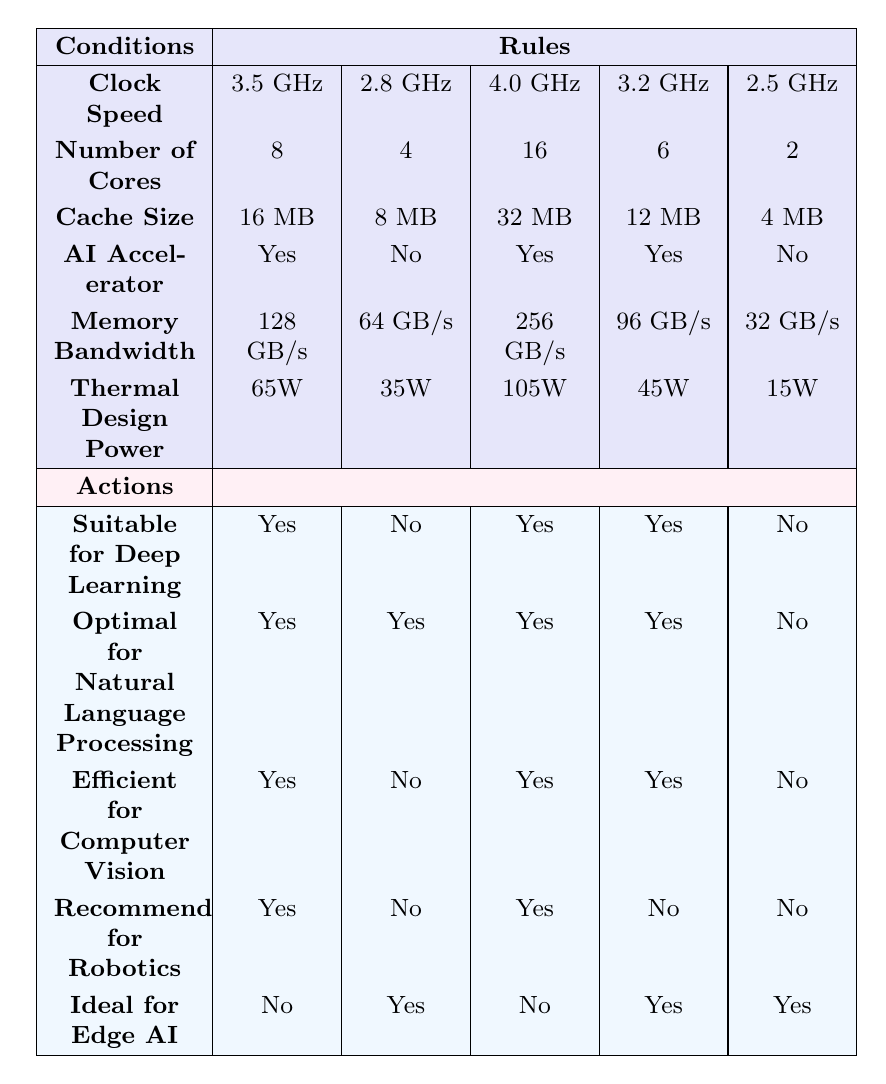What is the clock speed of the microprocessor suitable for deep learning? There are three entries in the table that indicate suitability for deep learning: 3.5 GHz, 4.0 GHz, and 3.2 GHz. Among those, the clock speeds are 3.5 GHz (first entry), 4.0 GHz (third entry), and 3.2 GHz (fourth entry).
Answer: 3.5 GHz, 4.0 GHz, 3.2 GHz How many cores does the microprocessor with an AI accelerator have? The first, third, and fourth entries in the table have AI accelerators. Reviewing those entries, the first has 8 cores, the third has 16 cores, and the fourth has 6 cores. Thus, the cores with AI accelerators are 8, 16, and 6.
Answer: 8, 16, 6 Which microprocessor features suitable for edge AI? The only entries that qualify as ideal for Edge AI are the second, fourth, and fifth ones. The conditions for these entries are: the second has 2 cores, 32 GB/s memory bandwidth, and no AI accelerator; the fourth has 6 cores, 96 GB/s memory bandwidth, and yes to AI accelerators; and lastly, the fifth has 2 cores, 32 GB/s memory bandwidth, with no AI accelerator.
Answer: 2 cores, 6 cores (from second and fourth entries) Is the microprocessor with the highest thermal design power recommended for robotics? The third entry featuring a thermal design power of 105W is the highest in this comparison. In that entry, it is stated that it is recommended for robotics. Thus, we refer to this entry for the answer.
Answer: Yes What is the average cache size of microprocessors suitable for natural language processing? All microprocessors that are optimal for natural language processing are the first, second, third, and fourth entries corresponding to cache sizes of 16 MB, 8 MB, 32 MB, and 12 MB. The sum of these sizes equals 16 + 8 + 32 + 12 = 68 MB. Since there are four entries, the average is 68 / 4 = 17 MB.
Answer: 17 MB Which microprocessor can efficiently handle computer vision and has the lowest clock speed? The second entry does not qualify as efficient for computer vision, nor does the fifth entry because all other quartets have higher performances. Only the fourth entry with 3.2 GHz has efficiency in computer vision while denying others that capability.
Answer: 3.2 GHz Do all microprocessors with a clock speed of 3.5 GHz have an AI accelerator? The only entry with a clock speed of 3.5 GHz is the first, which has an AI accelerator, confirming the statement.
Answer: Yes How many microprocessors are suitable for both deep learning and natural language processing? Review the first, third, and fourth entries; all these entries are marked suitable for both applications. The total number meeting both metrics is three: first (3.5 GHz), third (4.0 GHz), and fourth (3.2 GHz).
Answer: 3 